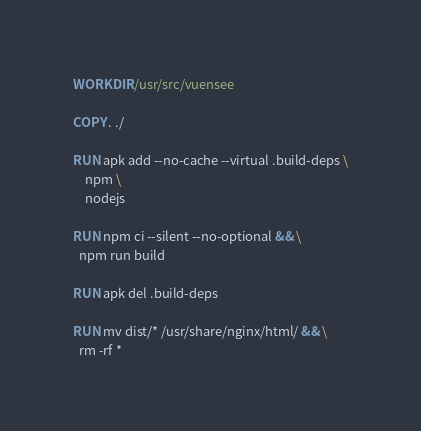<code> <loc_0><loc_0><loc_500><loc_500><_Dockerfile_>
WORKDIR /usr/src/vuensee

COPY . ./

RUN apk add --no-cache --virtual .build-deps \
    npm \
    nodejs

RUN npm ci --silent --no-optional && \
  npm run build

RUN apk del .build-deps

RUN mv dist/* /usr/share/nginx/html/ && \
  rm -rf *
</code> 